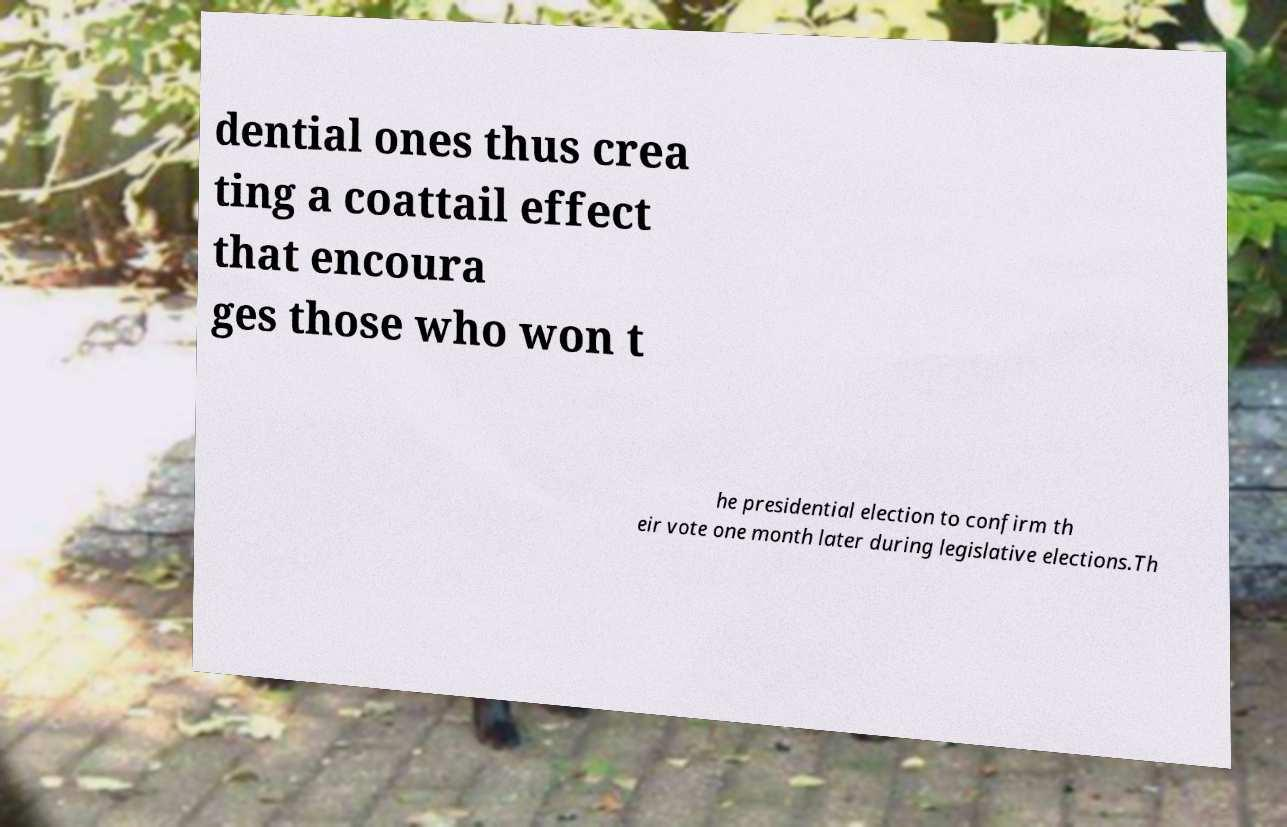Can you accurately transcribe the text from the provided image for me? dential ones thus crea ting a coattail effect that encoura ges those who won t he presidential election to confirm th eir vote one month later during legislative elections.Th 